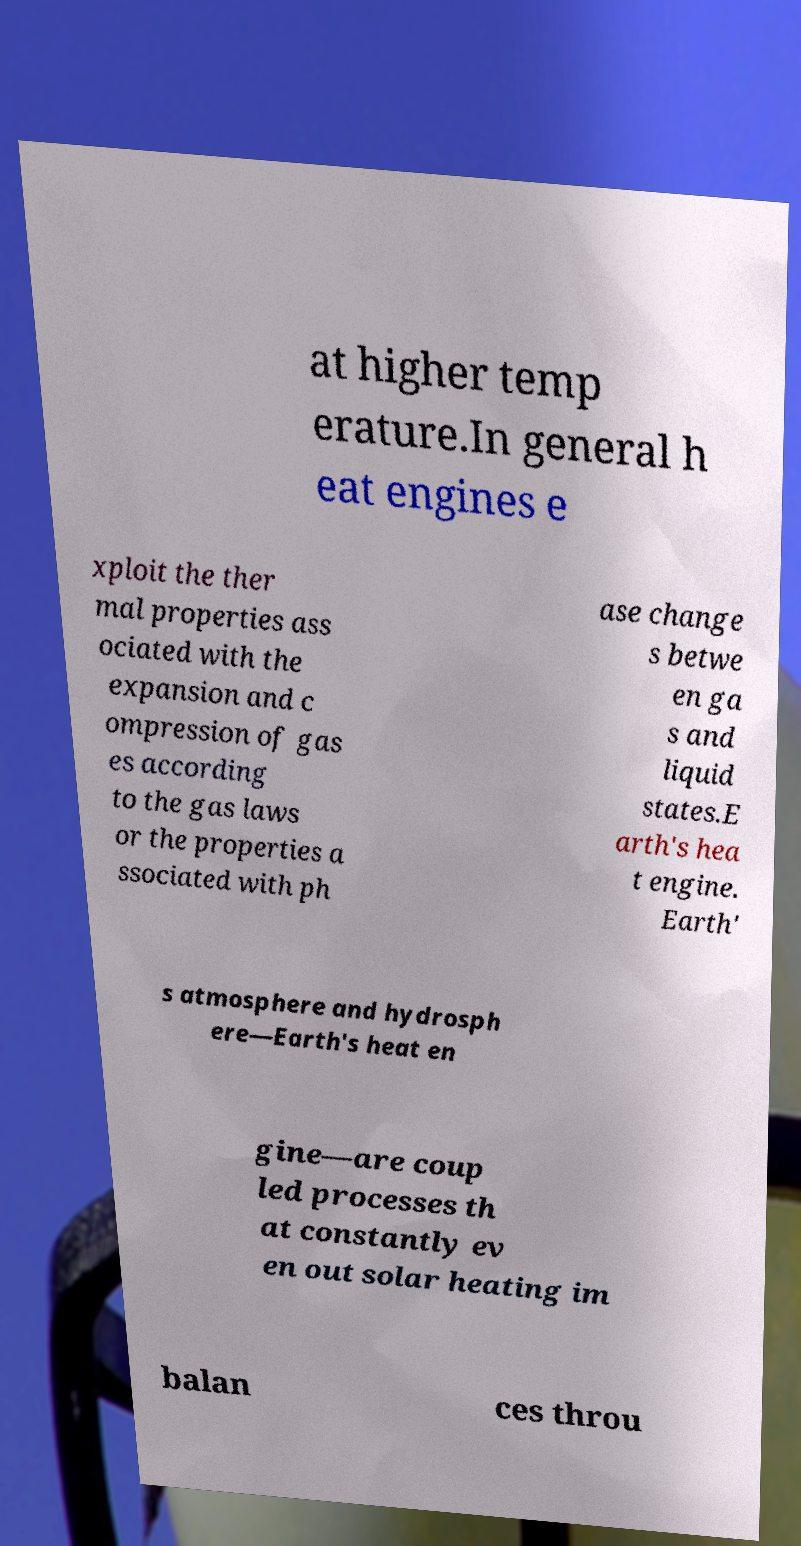I need the written content from this picture converted into text. Can you do that? at higher temp erature.In general h eat engines e xploit the ther mal properties ass ociated with the expansion and c ompression of gas es according to the gas laws or the properties a ssociated with ph ase change s betwe en ga s and liquid states.E arth's hea t engine. Earth' s atmosphere and hydrosph ere—Earth's heat en gine—are coup led processes th at constantly ev en out solar heating im balan ces throu 